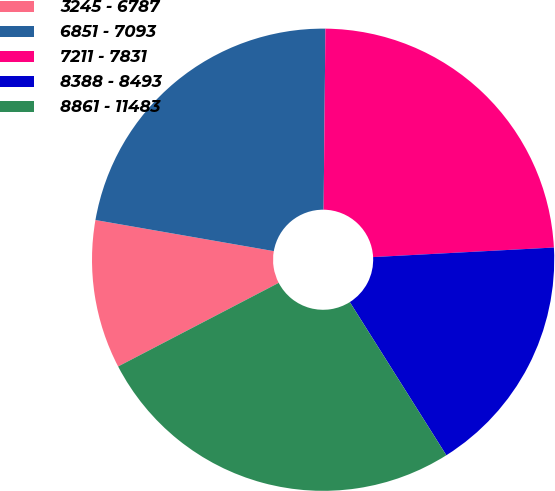Convert chart. <chart><loc_0><loc_0><loc_500><loc_500><pie_chart><fcel>3245 - 6787<fcel>6851 - 7093<fcel>7211 - 7831<fcel>8388 - 8493<fcel>8861 - 11483<nl><fcel>10.39%<fcel>22.41%<fcel>24.0%<fcel>16.89%<fcel>26.31%<nl></chart> 